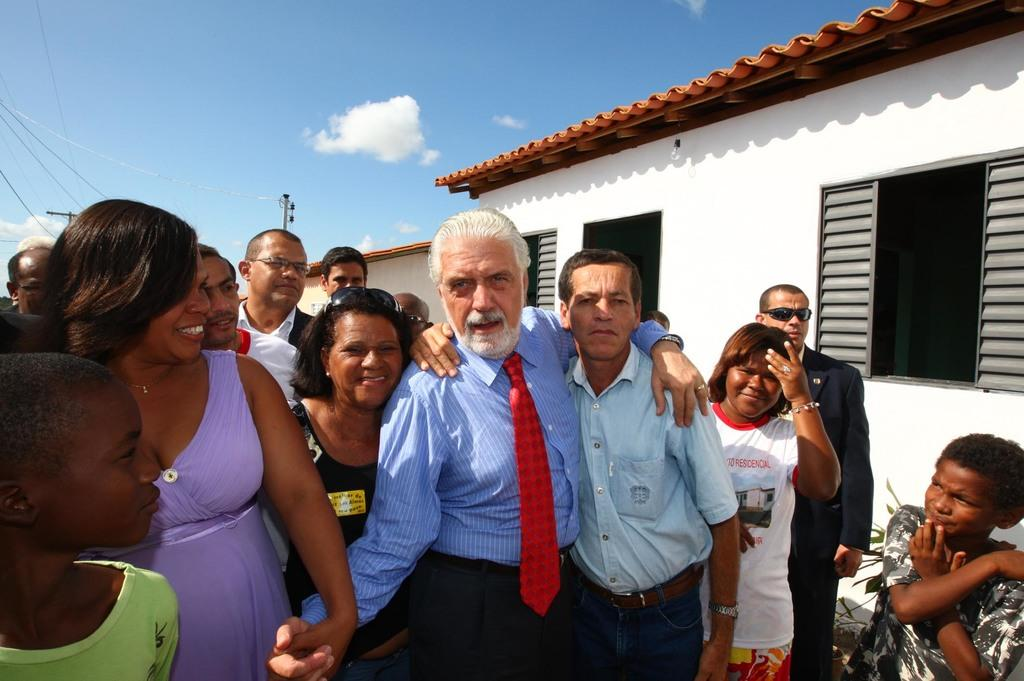What are the people in the image doing? The people in the image are standing in front of a house. What features can be seen on the house? The house has windows. What objects are visible behind the house? There are two poles behind the house. What is visible in the sky in the image? Clouds are visible in the sky. Is there a cable connecting the two poles behind the house? There is no mention of a cable connecting the two poles in the provided facts, so we cannot determine if one is present. Are the people in the image spying on the house? There is no indication in the image or the provided facts that the people are spying on the house. 